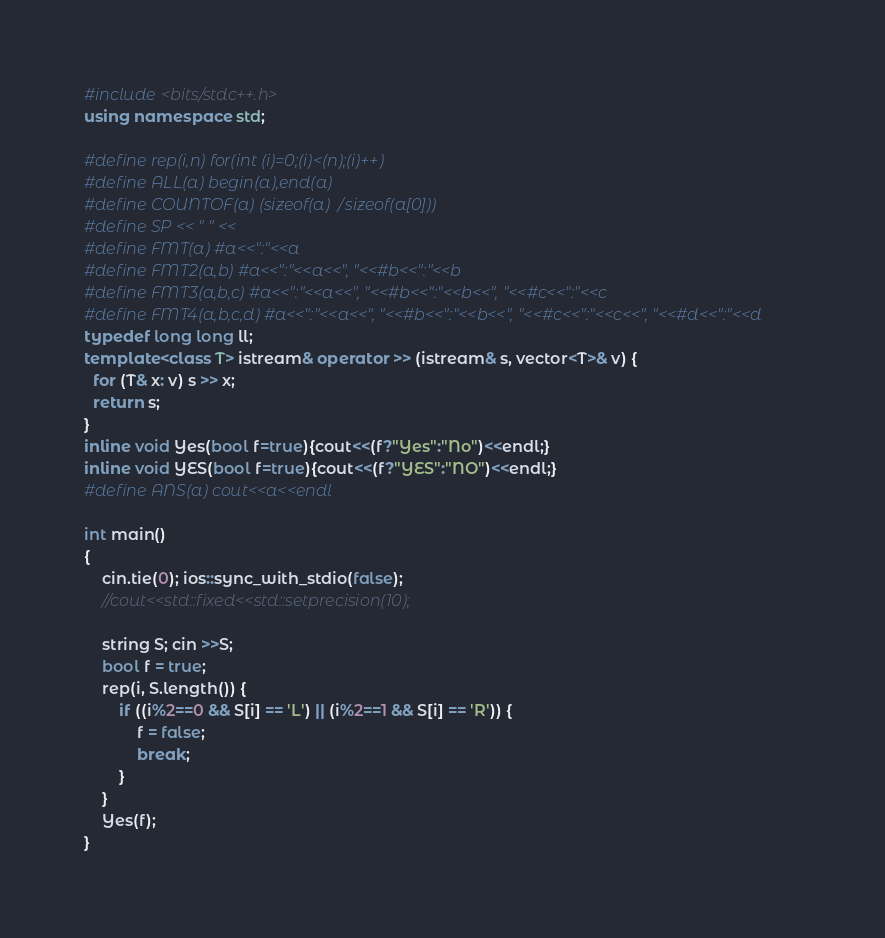<code> <loc_0><loc_0><loc_500><loc_500><_C++_>#include <bits/stdc++.h>
using namespace std;

#define rep(i,n) for(int (i)=0;(i)<(n);(i)++)
#define ALL(a) begin(a),end(a)
#define COUNTOF(a) (sizeof(a)/sizeof(a[0]))
#define SP << " " <<
#define FMT(a) #a<<":"<<a 
#define FMT2(a,b) #a<<":"<<a<<", "<<#b<<":"<<b 
#define FMT3(a,b,c) #a<<":"<<a<<", "<<#b<<":"<<b<<", "<<#c<<":"<<c 
#define FMT4(a,b,c,d) #a<<":"<<a<<", "<<#b<<":"<<b<<", "<<#c<<":"<<c<<", "<<#d<<":"<<d 
typedef long long ll;
template<class T> istream& operator >> (istream& s, vector<T>& v) {
  for (T& x: v) s >> x;
  return s;
}
inline void Yes(bool f=true){cout<<(f?"Yes":"No")<<endl;}
inline void YES(bool f=true){cout<<(f?"YES":"NO")<<endl;}
#define ANS(a) cout<<a<<endl

int main()
{
    cin.tie(0); ios::sync_with_stdio(false);
    //cout<<std::fixed<<std::setprecision(10);

    string S; cin >>S;
    bool f = true;
    rep(i, S.length()) {
        if ((i%2==0 && S[i] == 'L') || (i%2==1 && S[i] == 'R')) {
            f = false;
            break;
        }
    }
    Yes(f);
}
</code> 